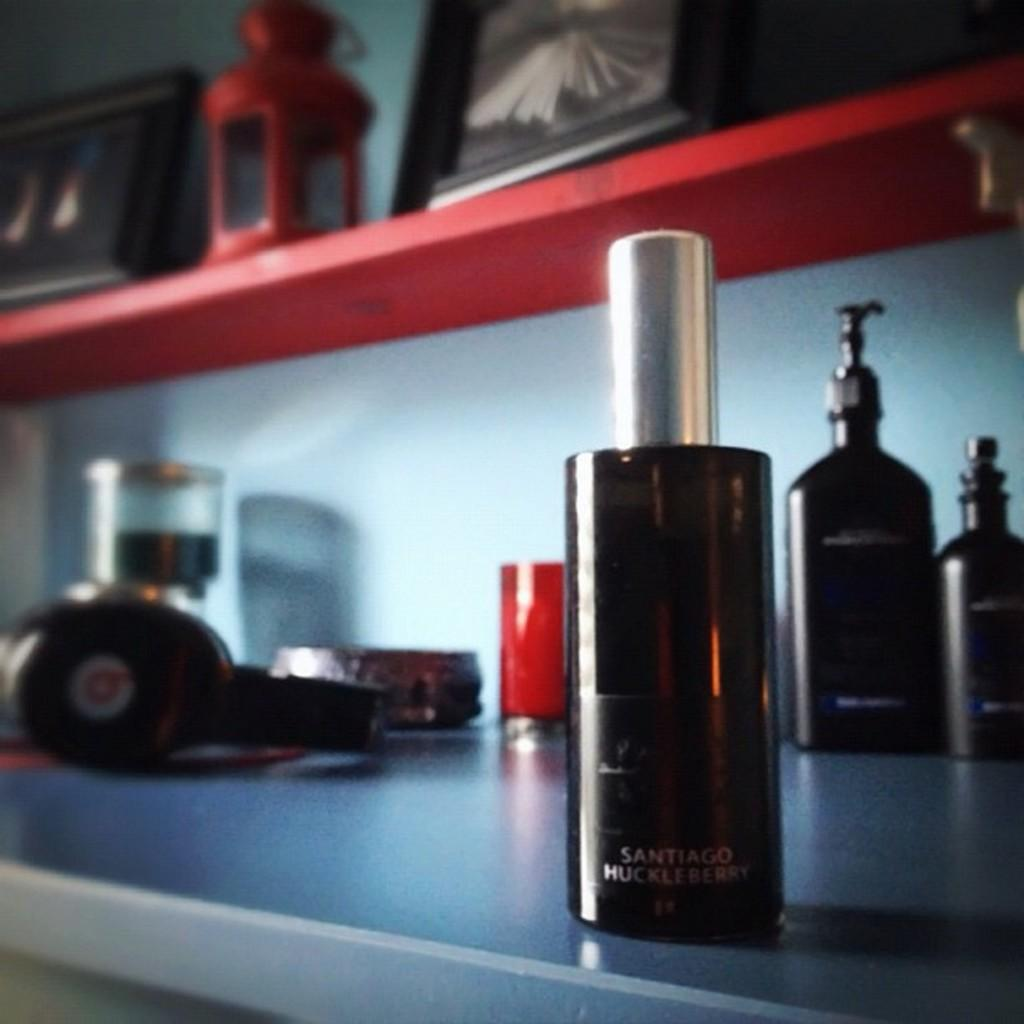Provide a one-sentence caption for the provided image. A spray bottle of Santiago Huckleberry sits on a counter along with many other items. 